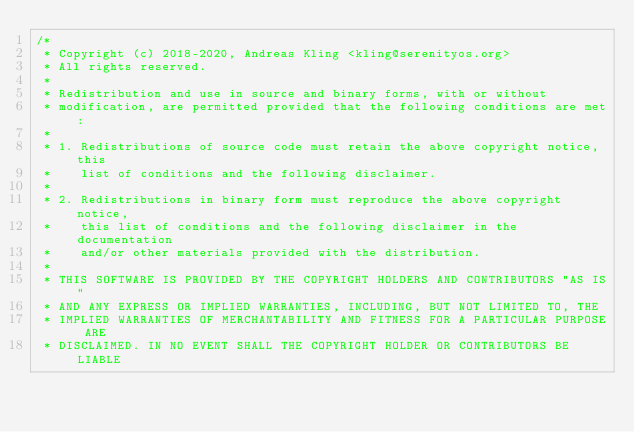Convert code to text. <code><loc_0><loc_0><loc_500><loc_500><_C_>/*
 * Copyright (c) 2018-2020, Andreas Kling <kling@serenityos.org>
 * All rights reserved.
 *
 * Redistribution and use in source and binary forms, with or without
 * modification, are permitted provided that the following conditions are met:
 *
 * 1. Redistributions of source code must retain the above copyright notice, this
 *    list of conditions and the following disclaimer.
 *
 * 2. Redistributions in binary form must reproduce the above copyright notice,
 *    this list of conditions and the following disclaimer in the documentation
 *    and/or other materials provided with the distribution.
 *
 * THIS SOFTWARE IS PROVIDED BY THE COPYRIGHT HOLDERS AND CONTRIBUTORS "AS IS"
 * AND ANY EXPRESS OR IMPLIED WARRANTIES, INCLUDING, BUT NOT LIMITED TO, THE
 * IMPLIED WARRANTIES OF MERCHANTABILITY AND FITNESS FOR A PARTICULAR PURPOSE ARE
 * DISCLAIMED. IN NO EVENT SHALL THE COPYRIGHT HOLDER OR CONTRIBUTORS BE LIABLE</code> 